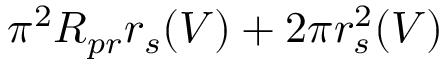Convert formula to latex. <formula><loc_0><loc_0><loc_500><loc_500>\pi ^ { 2 } R _ { p r } r _ { s } ( V ) + 2 \pi r _ { s } ^ { 2 } ( V )</formula> 